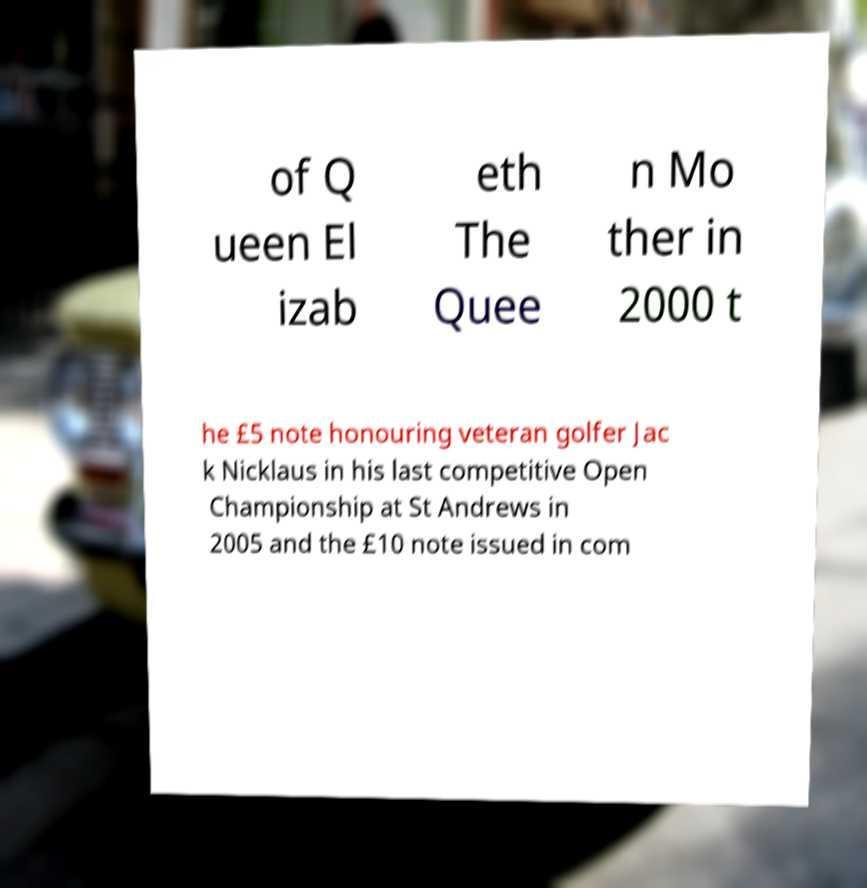Could you extract and type out the text from this image? of Q ueen El izab eth The Quee n Mo ther in 2000 t he £5 note honouring veteran golfer Jac k Nicklaus in his last competitive Open Championship at St Andrews in 2005 and the £10 note issued in com 